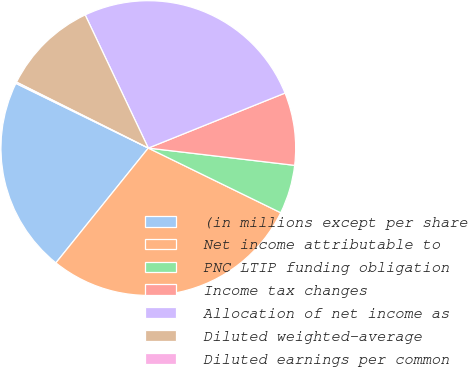Convert chart to OTSL. <chart><loc_0><loc_0><loc_500><loc_500><pie_chart><fcel>(in millions except per share<fcel>Net income attributable to<fcel>PNC LTIP funding obligation<fcel>Income tax changes<fcel>Allocation of net income as<fcel>Diluted weighted-average<fcel>Diluted earnings per common<nl><fcel>21.45%<fcel>28.56%<fcel>5.36%<fcel>7.96%<fcel>25.96%<fcel>10.57%<fcel>0.15%<nl></chart> 